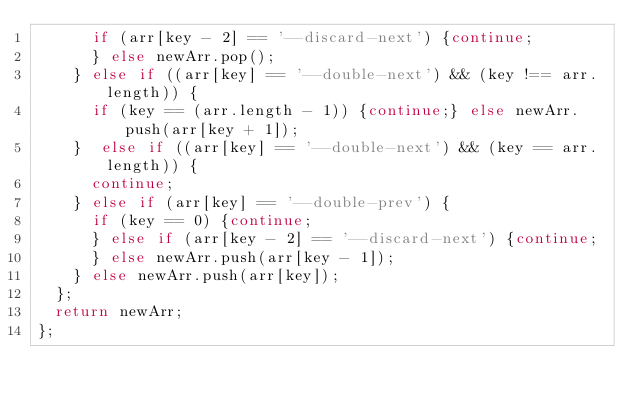<code> <loc_0><loc_0><loc_500><loc_500><_JavaScript_>      if (arr[key - 2] == '--discard-next') {continue;
      } else newArr.pop();
    } else if ((arr[key] == '--double-next') && (key !== arr.length)) {
      if (key == (arr.length - 1)) {continue;} else newArr.push(arr[key + 1]);
    }  else if ((arr[key] == '--double-next') && (key == arr.length)) {
      continue;
    } else if (arr[key] == '--double-prev') {
      if (key == 0) {continue;
      } else if (arr[key - 2] == '--discard-next') {continue;
      } else newArr.push(arr[key - 1]);
    } else newArr.push(arr[key]);
  };
  return newArr;
};
</code> 